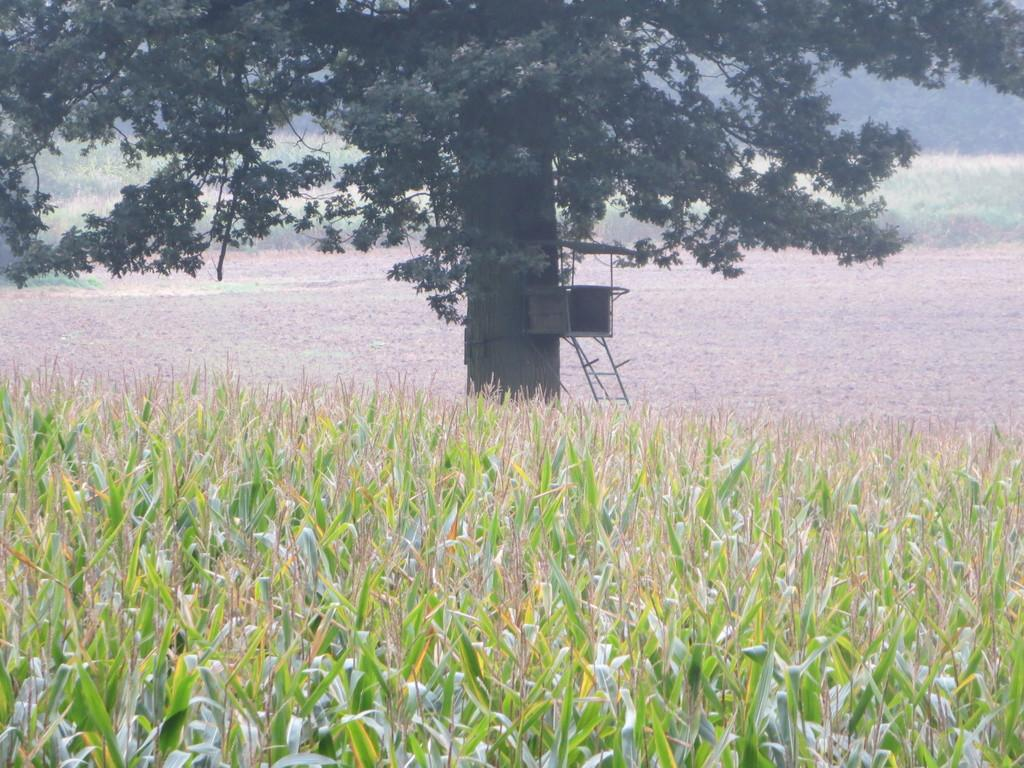What is the main subject in the center of the image? There is a tree in the center of the image. What other vegetation can be seen at the bottom of the image? There are plants at the bottom of the image. What type of natural environment is visible in the background of the image? There is grass visible in the background of the image. How many pins are attached to the tree in the image? There are no pins present in the image; it features a tree, plants, and grass. 